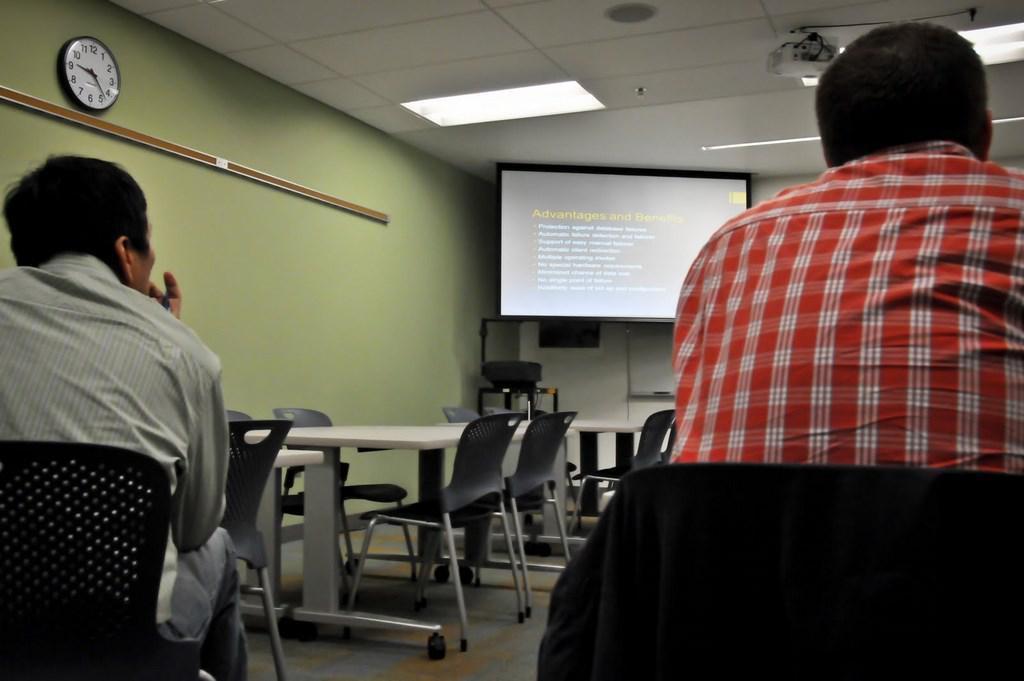Could you give a brief overview of what you see in this image? The image is inside the classroom. In the image on right side and left side there are two men's sitting on chair and we can also see a clock on left side, in background there is a screen on top there is a projector and roof with few lights. 